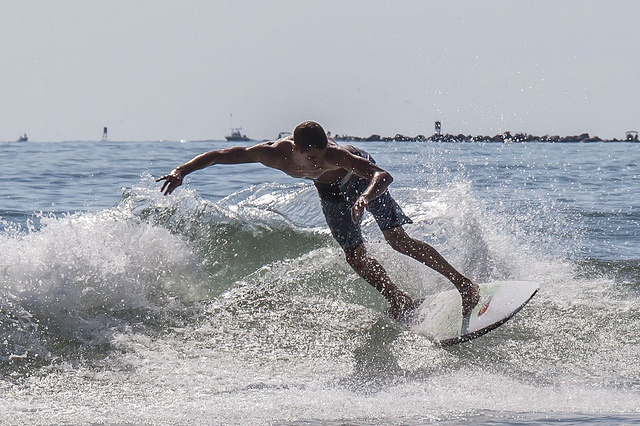Describe the objects in this image and their specific colors. I can see people in lightgray, black, gray, and darkgray tones, surfboard in lightgray, darkgray, gray, and black tones, boat in lightgray, gray, darkgray, and darkblue tones, and boat in lightgray, gray, and darkgray tones in this image. 